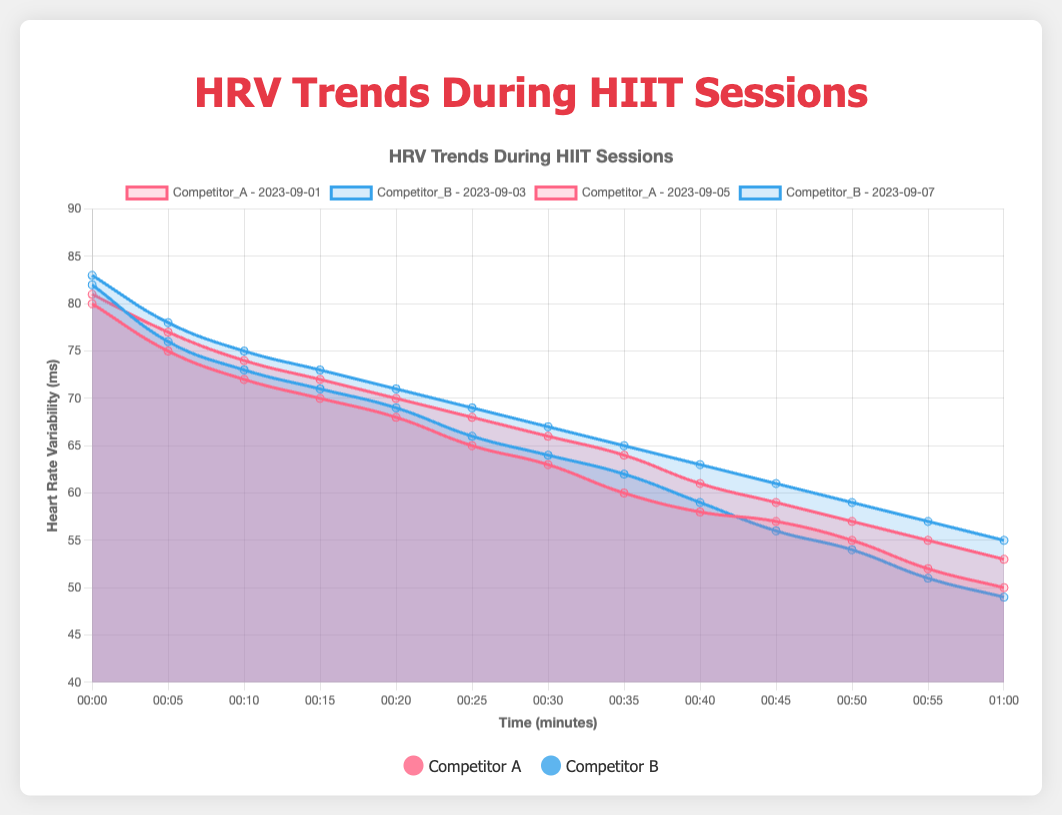Which athlete generally started their sessions with higher HRV values? To determine which athlete started with higher HRV values, look at the HRV values at the beginning (00:00) of each session. Competitor A started with HRV values of 80 and 81 in their sessions, while Competitor B had starting HRV values of 82 and 83. Therefore, Competitor B generally started with higher HRV values.
Answer: Competitor B On average, did Competitor A or Competitor B show a greater decrease in HRV during the sessions? First, calculate the decrease in HRV for each session by subtracting the HRV at the end (01:00) from the HRV at the beginning (00:00). For Competitor A: (80-50) = 30 and (81-53) = 28, averaging (30+28)/2 = 29. For Competitor B: (82-49) = 33 and (83-55) = 28, averaging (33+28)/2 = 30.5. Therefore, Competitor B showed a greater average decrease.
Answer: Competitor B Which session showed the smallest decrease in HRV? To find the smallest decrease, calculate the HRV decrease for each session: Competitor A's sessions: (80-50) = 30 and (81-53) = 28; Competitor B's sessions: (82-49) = 33 and (83-55) = 28. Both Competitor A's second session and Competitor B's second session had the smallest decrease, which is 28.
Answer: Competitor A (Sept 5) and Competitor B (Sept 7) Who had the more consistent HRV decline throughout their sessions, Competitor A or Competitor B? Consistency can be assessed by the similarity of HRV declines. Competitor A had declines of 30 and 28, varying by 2 units. Competitor B had declines of 33 and 28, varying by 5 units. Since Competitor A's variation (2 units) is smaller, Competitor A had the more consistent HRV decline.
Answer: Competitor A At the 30-minute mark of their sessions, which competitor typically had a higher HRV? Look at the HRV values at the 30-minute mark for all sessions. For Competitor A, the values are 63 and 66; for Competitor B, they are 64 and 67. Averaging these: Competitor A = (63+66)/2 = 64.5, Competitor B = (64+67)/2 = 65.5. Therefore, Competitor B typically had a higher HRV at the 30-minute mark.
Answer: Competitor B Which athlete showed a steadier rate of HRV decline in each of their sessions, based on visual trends? A steadier rate of decline will appear as a more linear descent on the plot. Examining the plotted lines visually, Competitor A's sessions show a steadier and more linear decline compared to Competitor B's sessions, which have a more variable slope.
Answer: Competitor A Did any athlete see an increase in HRV during any point of their sessions? If yes, which athlete and when? To identify increases, examine if any HRV value at one time point is higher than the previous value. Checking the data for all sessions, neither Competitor A nor Competitor B has any instance where HRV increased during the sessions, as all values consistently decreased over time.
Answer: No 